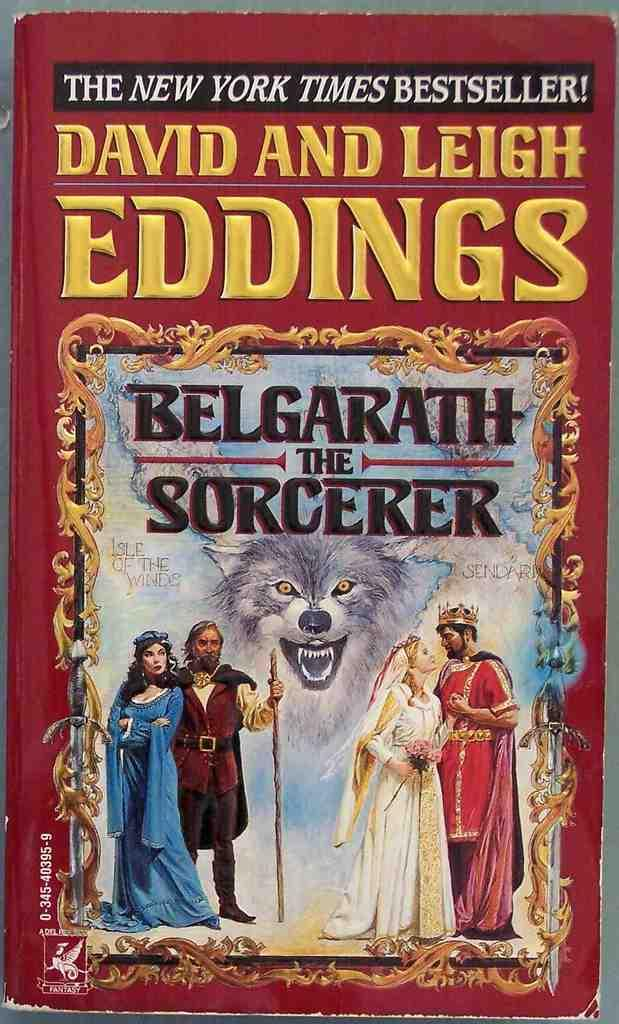Provide a one-sentence caption for the provided image. Paperback NEW YORK TIMES BEST SELLER of Belgarath the Sorcerer by David and Leigh Eddings. 